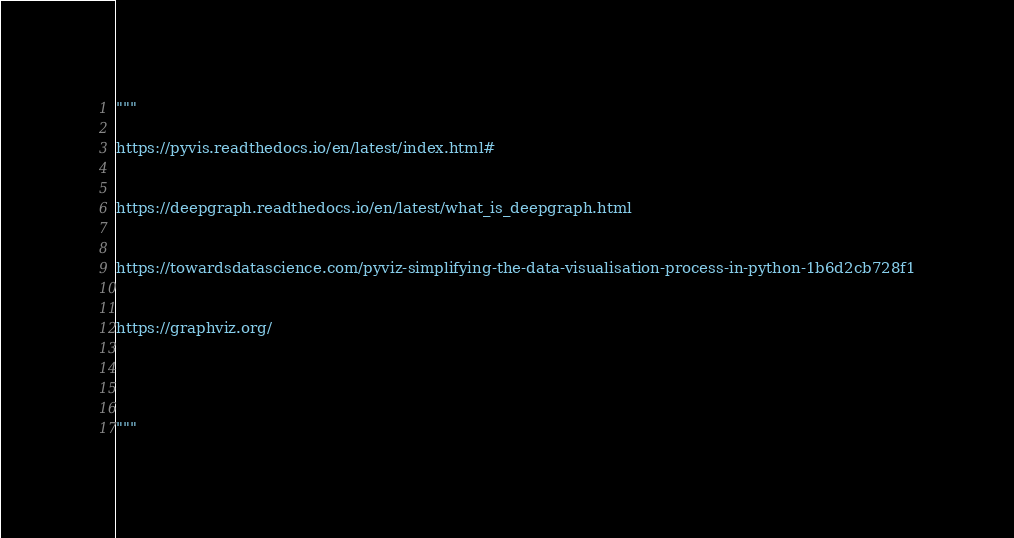<code> <loc_0><loc_0><loc_500><loc_500><_Python_>"""

https://pyvis.readthedocs.io/en/latest/index.html#


https://deepgraph.readthedocs.io/en/latest/what_is_deepgraph.html


https://towardsdatascience.com/pyviz-simplifying-the-data-visualisation-process-in-python-1b6d2cb728f1


https://graphviz.org/




"""
</code> 